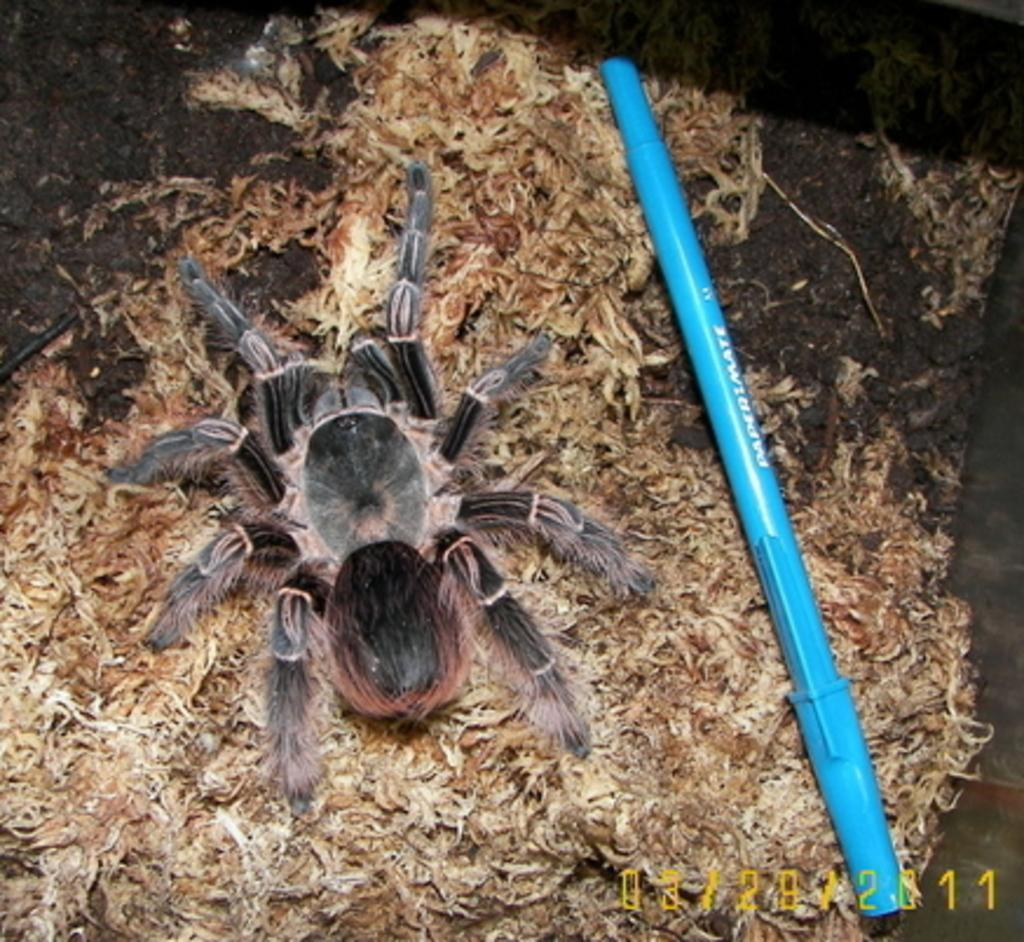What is the main subject of the image? There is a spider in the image. Can you describe the appearance of the spider? The spider has grey and black colors. What other object can be seen in the image? There is a blue color pen in the image. Is there any additional feature on the image? Yes, there is a watermark in the image. Can you tell me how many leaves are on the spider's back in the image? There are no leaves present in the image, as it features a spider and a blue color pen. 